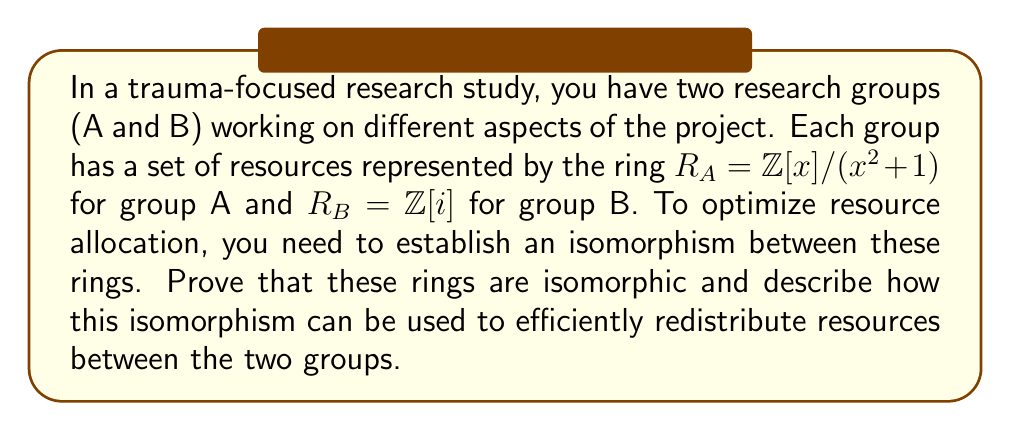Show me your answer to this math problem. To prove that $R_A = \mathbb{Z}[x]/(x^2 + 1)$ and $R_B = \mathbb{Z}[i]$ are isomorphic, we need to construct a ring homomorphism between them and show that it is bijective.

1. Define a map $\phi: R_A \to R_B$ as follows:
   $\phi(a + bx) = a + bi$ for $a, b \in \mathbb{Z}$

2. Prove that $\phi$ is a ring homomorphism:
   a) $\phi((a_1 + b_1x) + (a_2 + b_2x)) = \phi((a_1 + a_2) + (b_1 + b_2)x) = (a_1 + a_2) + (b_1 + b_2)i = (a_1 + b_1i) + (a_2 + b_2i) = \phi(a_1 + b_1x) + \phi(a_2 + b_2x)$
   b) $\phi((a_1 + b_1x)(a_2 + b_2x)) = \phi((a_1a_2 - b_1b_2) + (a_1b_2 + a_2b_1)x) = (a_1a_2 - b_1b_2) + (a_1b_2 + a_2b_1)i = (a_1 + b_1i)(a_2 + b_2i) = \phi(a_1 + b_1x)\phi(a_2 + b_2x)$
   c) $\phi(1) = 1$

3. Prove that $\phi$ is injective:
   If $\phi(a + bx) = 0$, then $a + bi = 0$, which implies $a = b = 0$. Therefore, $\ker(\phi) = \{0\}$, so $\phi$ is injective.

4. Prove that $\phi$ is surjective:
   For any $a + bi \in \mathbb{Z}[i]$, there exists $a + bx \in \mathbb{Z}[x]/(x^2 + 1)$ such that $\phi(a + bx) = a + bi$. Therefore, $\phi$ is surjective.

Since $\phi$ is a bijective ring homomorphism, it is an isomorphism between $R_A$ and $R_B$.

To use this isomorphism for efficient resource redistribution:

1. Create a one-to-one correspondence between resources in group A and group B using $\phi$.
2. When transferring resources from A to B, use $\phi$ to map the resources.
3. When transferring resources from B to A, use $\phi^{-1}$ to map the resources.

This isomorphism ensures that the resource structure and relationships are preserved when redistributing between groups, maintaining the integrity of the research project while optimizing resource allocation.
Answer: The rings $R_A = \mathbb{Z}[x]/(x^2 + 1)$ and $R_B = \mathbb{Z}[i]$ are isomorphic via the isomorphism $\phi: R_A \to R_B$ defined by $\phi(a + bx) = a + bi$ for $a, b \in \mathbb{Z}$. This isomorphism can be used to create a one-to-one correspondence between resources in groups A and B, allowing for efficient redistribution while preserving the resource structure and relationships. 